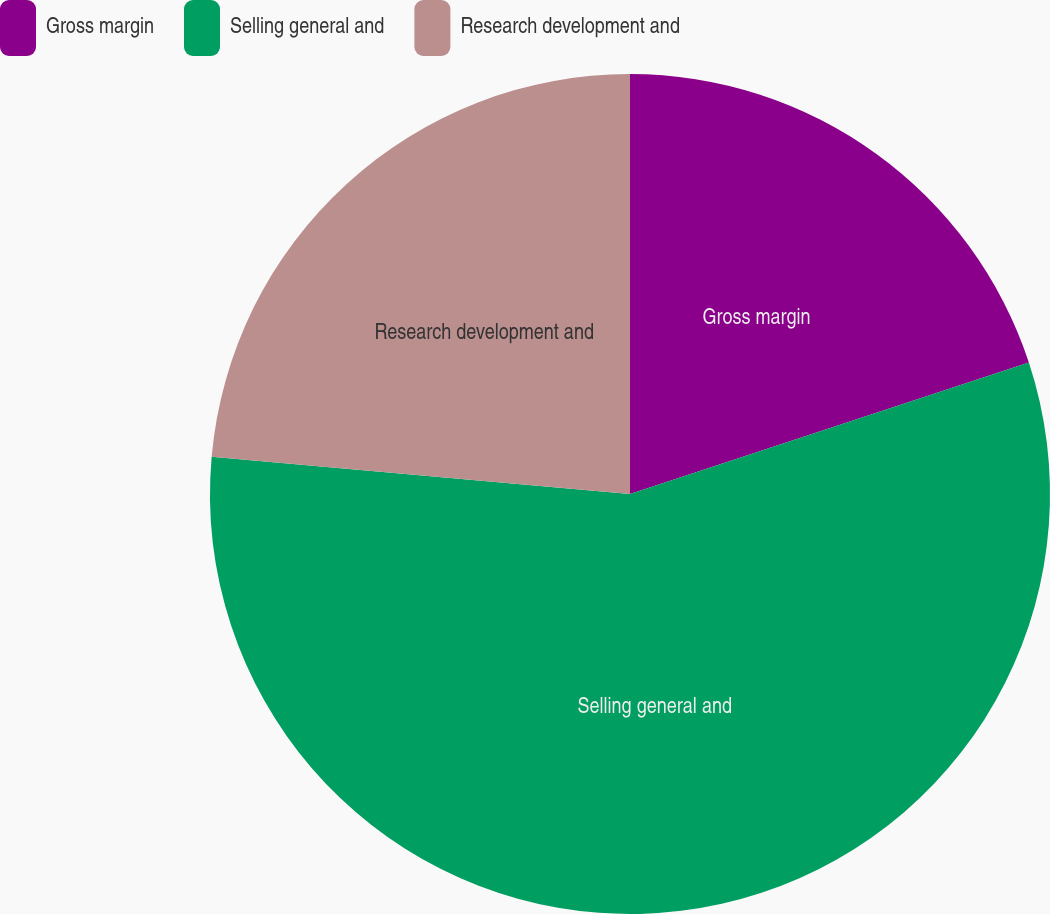Convert chart. <chart><loc_0><loc_0><loc_500><loc_500><pie_chart><fcel>Gross margin<fcel>Selling general and<fcel>Research development and<nl><fcel>19.93%<fcel>56.48%<fcel>23.59%<nl></chart> 